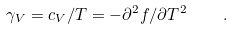Convert formula to latex. <formula><loc_0><loc_0><loc_500><loc_500>\gamma _ { V } = c _ { V } / T = - \partial ^ { 2 } f / \partial T ^ { 2 } \quad .</formula> 